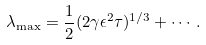<formula> <loc_0><loc_0><loc_500><loc_500>\lambda _ { \max } = \frac { 1 } { 2 } ( 2 \gamma \epsilon ^ { 2 } \tau ) ^ { 1 / 3 } + \cdots \, .</formula> 